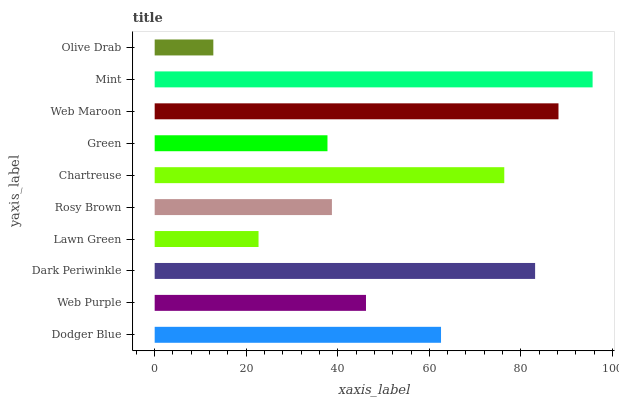Is Olive Drab the minimum?
Answer yes or no. Yes. Is Mint the maximum?
Answer yes or no. Yes. Is Web Purple the minimum?
Answer yes or no. No. Is Web Purple the maximum?
Answer yes or no. No. Is Dodger Blue greater than Web Purple?
Answer yes or no. Yes. Is Web Purple less than Dodger Blue?
Answer yes or no. Yes. Is Web Purple greater than Dodger Blue?
Answer yes or no. No. Is Dodger Blue less than Web Purple?
Answer yes or no. No. Is Dodger Blue the high median?
Answer yes or no. Yes. Is Web Purple the low median?
Answer yes or no. Yes. Is Mint the high median?
Answer yes or no. No. Is Olive Drab the low median?
Answer yes or no. No. 